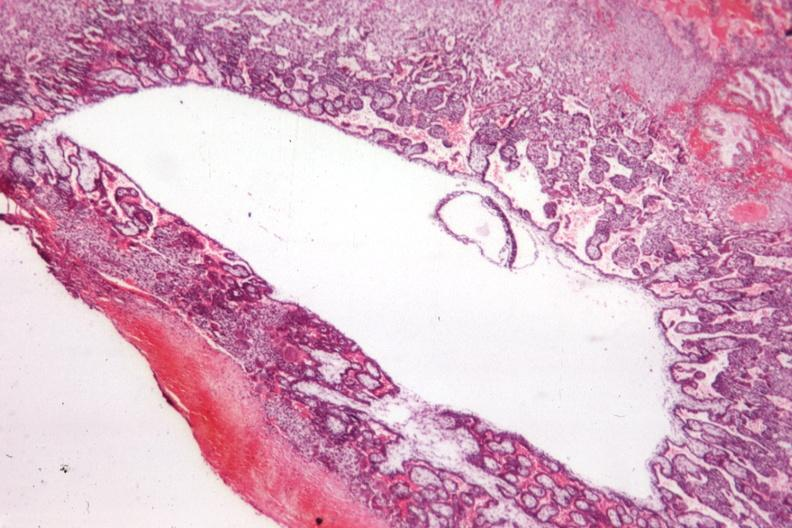what is present?
Answer the question using a single word or phrase. Female reproductive 